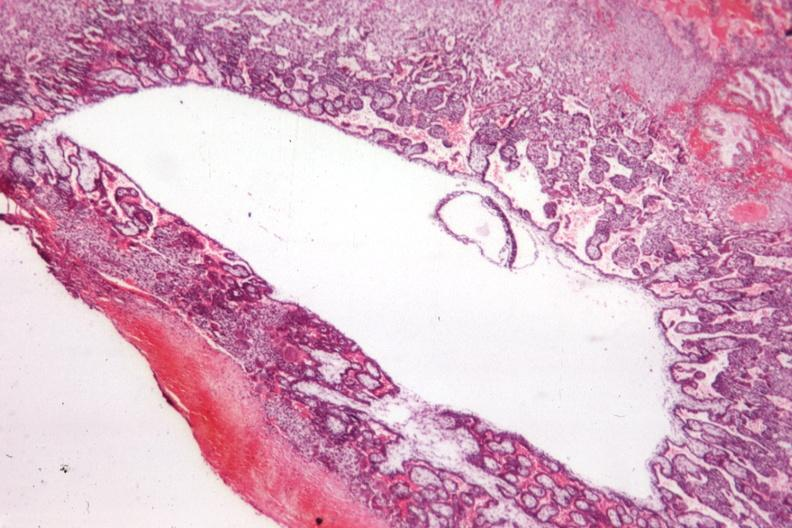what is present?
Answer the question using a single word or phrase. Female reproductive 